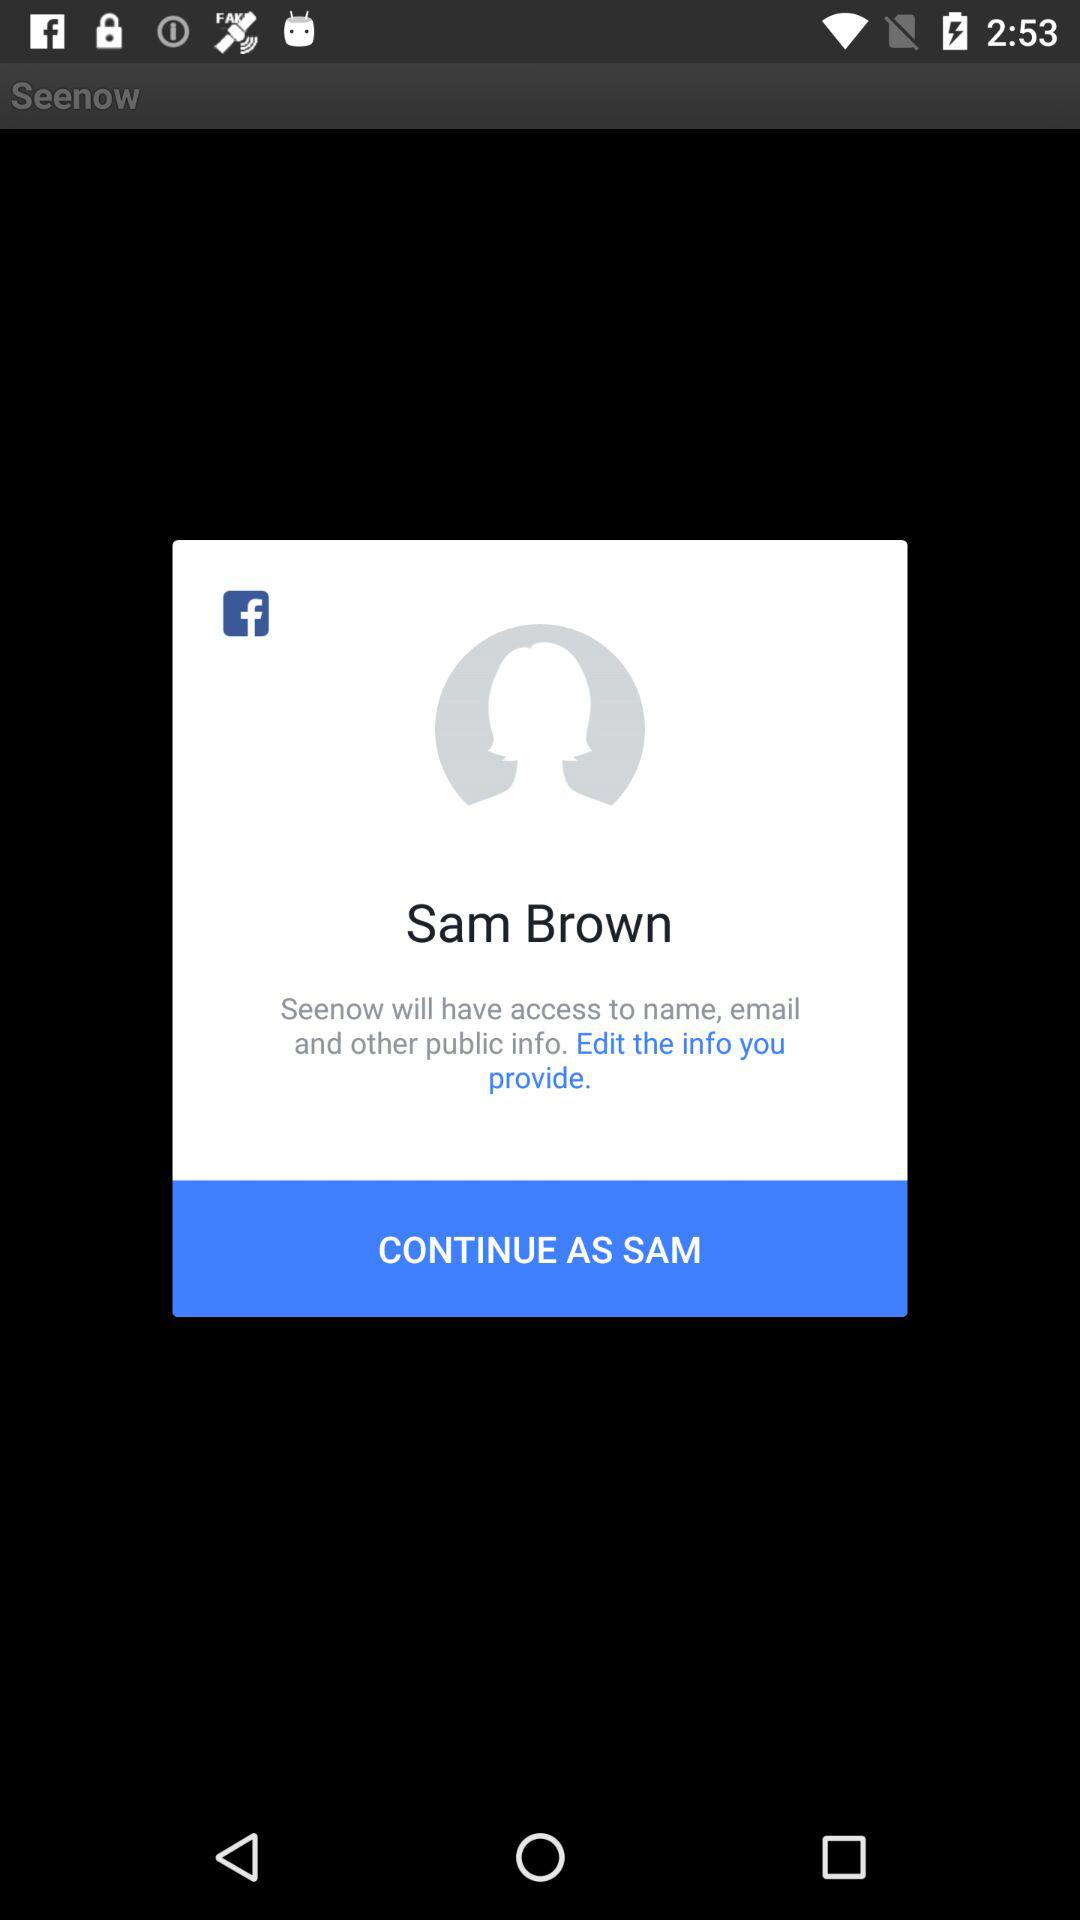How many public information categories does Seenow have access to?
Answer the question using a single word or phrase. 3 